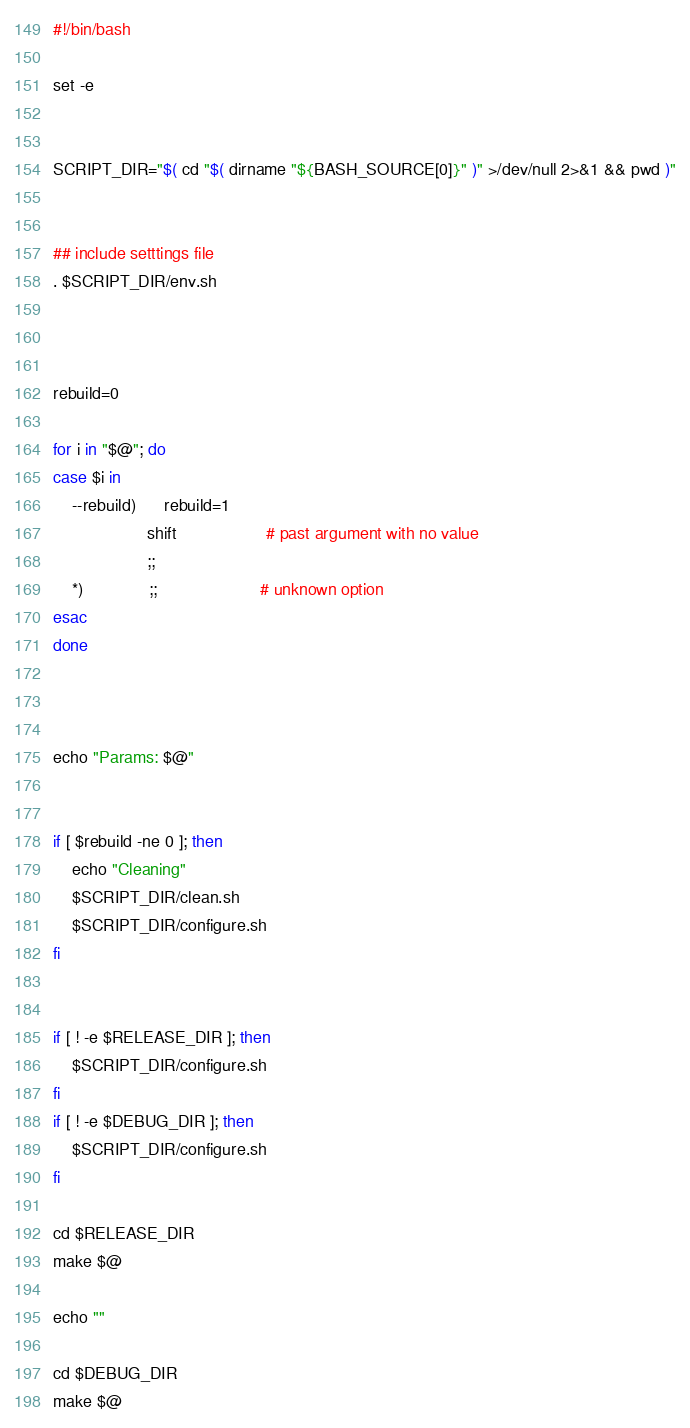<code> <loc_0><loc_0><loc_500><loc_500><_Bash_>#!/bin/bash

set -e


SCRIPT_DIR="$( cd "$( dirname "${BASH_SOURCE[0]}" )" >/dev/null 2>&1 && pwd )"


## include setttings file
. $SCRIPT_DIR/env.sh



rebuild=0

for i in "$@"; do
case $i in
    --rebuild)      rebuild=1
                    shift                   # past argument with no value
                    ;;
    *)              ;;                      # unknown option
esac
done



echo "Params: $@"


if [ $rebuild -ne 0 ]; then
    echo "Cleaning"
    $SCRIPT_DIR/clean.sh
    $SCRIPT_DIR/configure.sh
fi


if [ ! -e $RELEASE_DIR ]; then
    $SCRIPT_DIR/configure.sh
fi
if [ ! -e $DEBUG_DIR ]; then
    $SCRIPT_DIR/configure.sh
fi

cd $RELEASE_DIR
make $@

echo ""

cd $DEBUG_DIR
make $@
</code> 